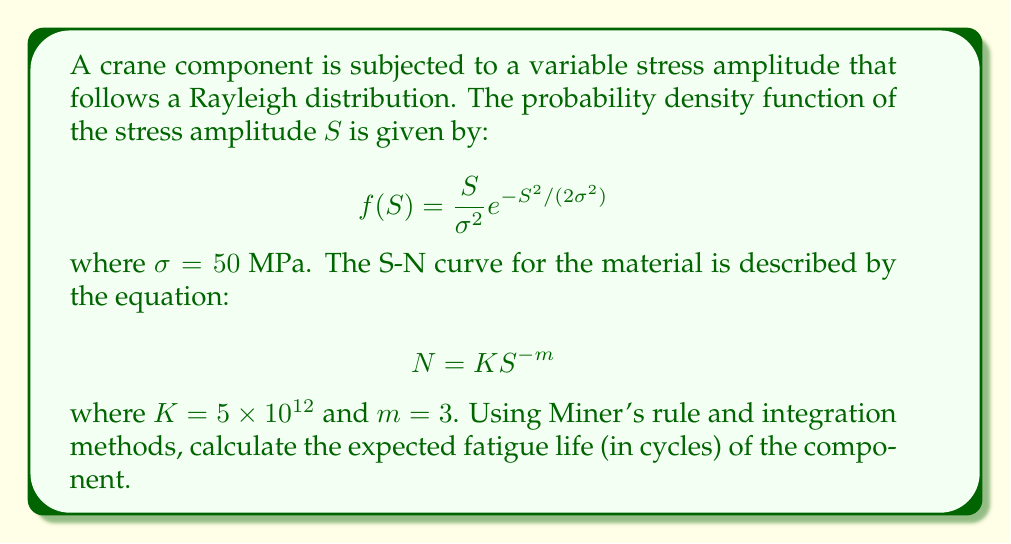Show me your answer to this math problem. To solve this problem, we'll follow these steps:

1) According to Miner's rule, the cumulative damage $D$ is given by:

   $$D = \int_0^{\infty} \frac{f(S)}{N(S)} dS$$

   where $f(S)$ is the probability density function of stress and $N(S)$ is the number of cycles to failure at stress $S$.

2) Substituting the given functions:

   $$D = \int_0^{\infty} \frac{S}{\sigma^2} e^{-S^2/(2\sigma^2)} \cdot \frac{1}{K S^{-m}} dS$$

3) Simplifying:

   $$D = \frac{1}{K\sigma^2} \int_0^{\infty} S^{m+1} e^{-S^2/(2\sigma^2)} dS$$

4) This integral can be solved using the gamma function. The solution is:

   $$D = \frac{1}{K\sigma^2} \cdot \sigma^{m+2} \cdot 2^{(m+2)/2} \cdot \Gamma\left(\frac{m+2}{2}\right)$$

5) Substituting the given values ($\sigma = 50$ MPa, $K = 5 \times 10^{12}$, $m = 3$):

   $$D = \frac{1}{5 \times 10^{12} \cdot 50^2} \cdot 50^5 \cdot 2^{5/2} \cdot \Gamma\left(\frac{5}{2}\right)$$

6) Simplifying:

   $$D = \frac{50^3 \cdot 2^{5/2}}{5 \times 10^{12}} \cdot \Gamma\left(\frac{5}{2}\right)$$

7) $\Gamma(5/2) = 3\sqrt{\pi}/4$, so:

   $$D = \frac{50^3 \cdot 2^{5/2}}{5 \times 10^{12}} \cdot \frac{3\sqrt{\pi}}{4}$$

8) The expected fatigue life is the reciprocal of $D$:

   $$\text{Expected Fatigue Life} = \frac{1}{D} = \frac{5 \times 10^{12}}{50^3 \cdot 2^{5/2} \cdot 3\sqrt{\pi}/4}$$

9) Calculating this value gives approximately 2,388,320 cycles.
Answer: 2,388,320 cycles 